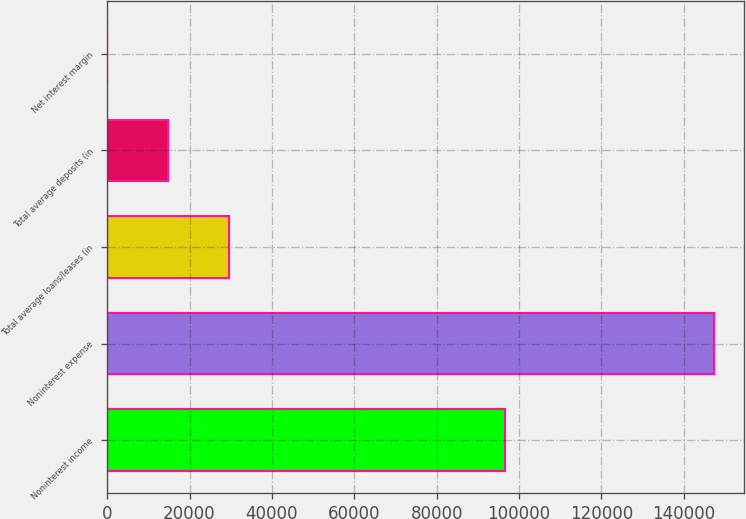Convert chart to OTSL. <chart><loc_0><loc_0><loc_500><loc_500><bar_chart><fcel>Noninterest income<fcel>Noninterest expense<fcel>Total average loans/leases (in<fcel>Total average deposits (in<fcel>Net interest margin<nl><fcel>96676<fcel>147329<fcel>29468.8<fcel>14736.3<fcel>3.79<nl></chart> 